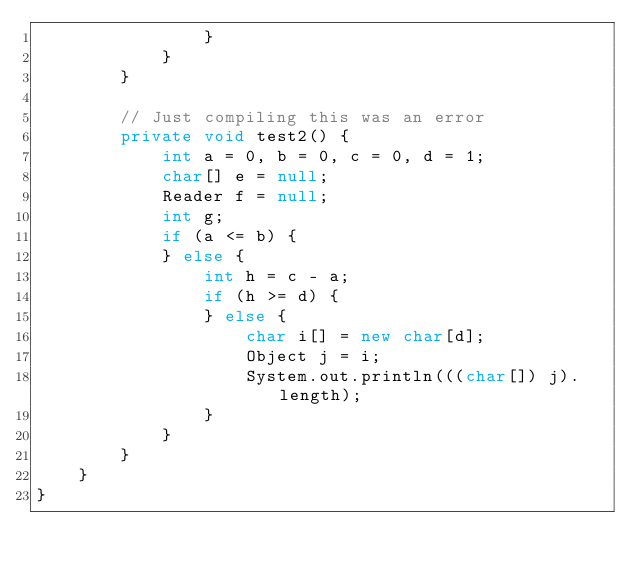<code> <loc_0><loc_0><loc_500><loc_500><_Java_>                }
            }
        }

        // Just compiling this was an error
        private void test2() {
            int a = 0, b = 0, c = 0, d = 1;
            char[] e = null;
            Reader f = null;
            int g;
            if (a <= b) {
            } else {
                int h = c - a;
                if (h >= d) {
                } else {
                    char i[] = new char[d];
                    Object j = i;
                    System.out.println(((char[]) j).length);
                }
            }
        }
    }
}
</code> 